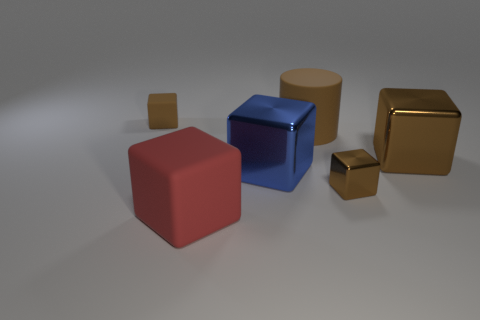Subtract all green balls. How many brown cubes are left? 3 Subtract 2 cubes. How many cubes are left? 3 Subtract all brown matte blocks. How many blocks are left? 4 Subtract all purple cubes. Subtract all green spheres. How many cubes are left? 5 Add 1 large red metal cylinders. How many objects exist? 7 Subtract all cylinders. How many objects are left? 5 Add 1 big shiny cubes. How many big shiny cubes are left? 3 Add 4 brown objects. How many brown objects exist? 8 Subtract 0 yellow cubes. How many objects are left? 6 Subtract all large matte blocks. Subtract all rubber blocks. How many objects are left? 3 